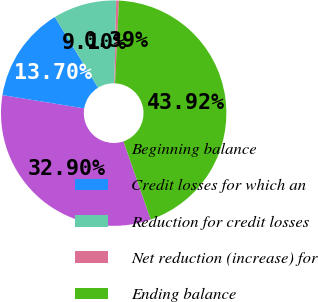<chart> <loc_0><loc_0><loc_500><loc_500><pie_chart><fcel>Beginning balance<fcel>Credit losses for which an<fcel>Reduction for credit losses<fcel>Net reduction (increase) for<fcel>Ending balance<nl><fcel>32.9%<fcel>13.7%<fcel>9.1%<fcel>0.39%<fcel>43.92%<nl></chart> 